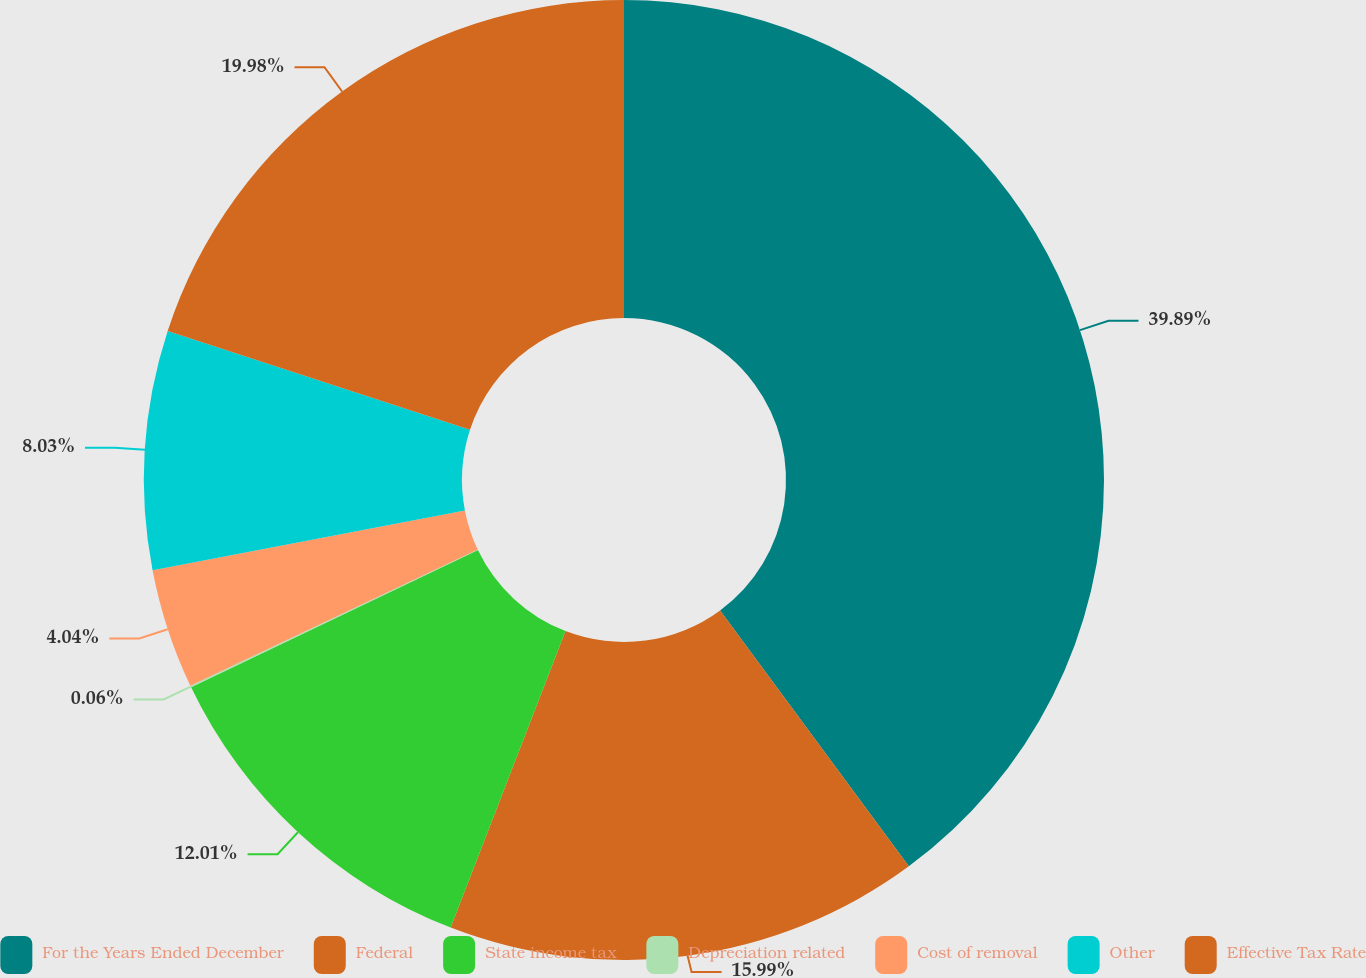<chart> <loc_0><loc_0><loc_500><loc_500><pie_chart><fcel>For the Years Ended December<fcel>Federal<fcel>State income tax<fcel>Depreciation related<fcel>Cost of removal<fcel>Other<fcel>Effective Tax Rate<nl><fcel>39.89%<fcel>15.99%<fcel>12.01%<fcel>0.06%<fcel>4.04%<fcel>8.03%<fcel>19.98%<nl></chart> 